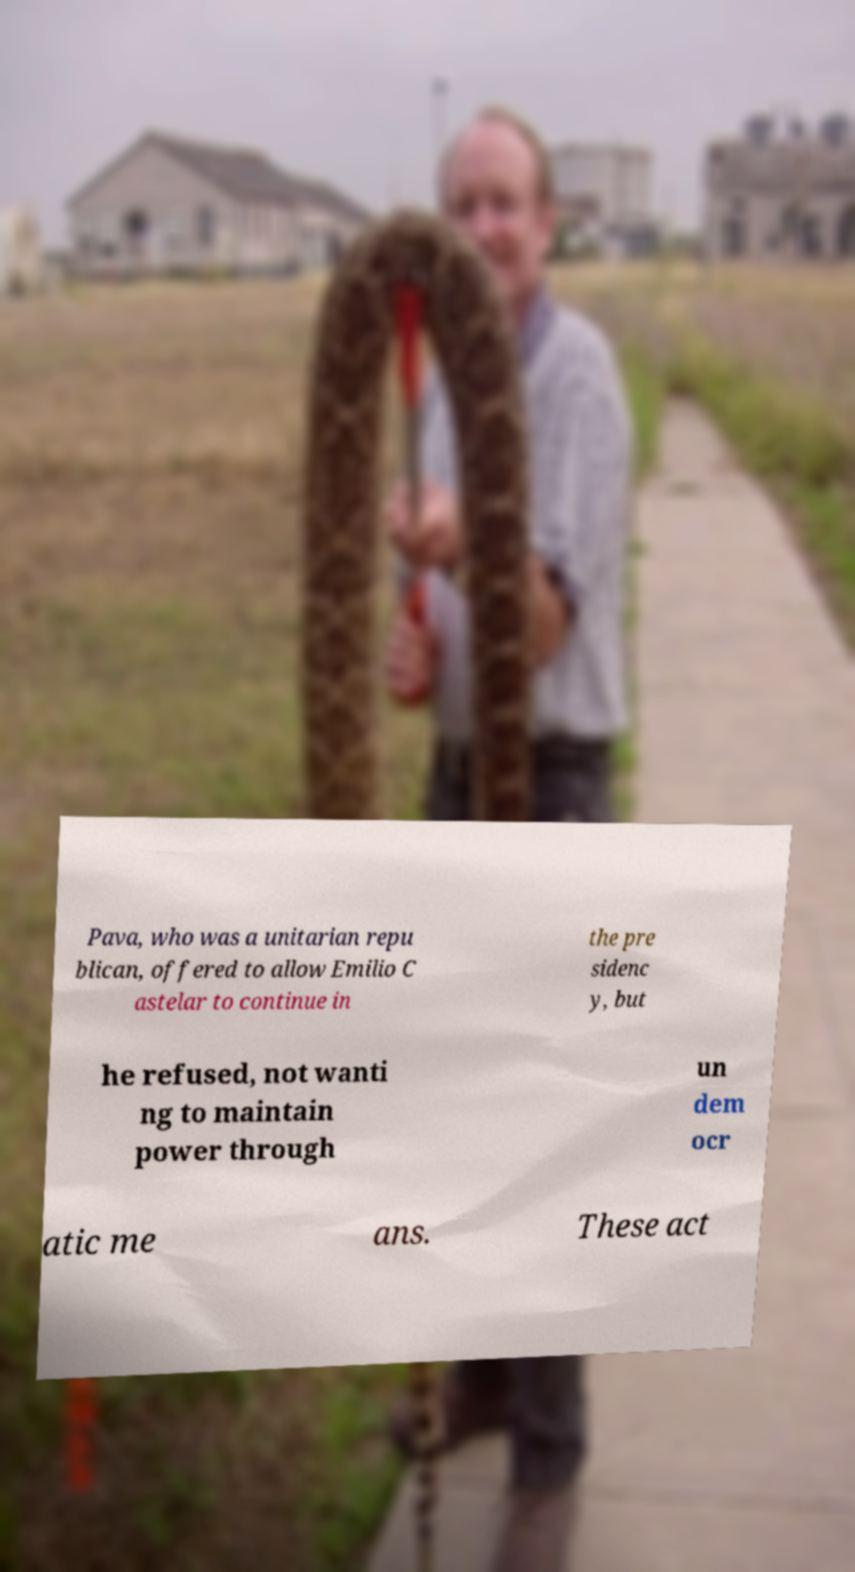What messages or text are displayed in this image? I need them in a readable, typed format. Pava, who was a unitarian repu blican, offered to allow Emilio C astelar to continue in the pre sidenc y, but he refused, not wanti ng to maintain power through un dem ocr atic me ans. These act 